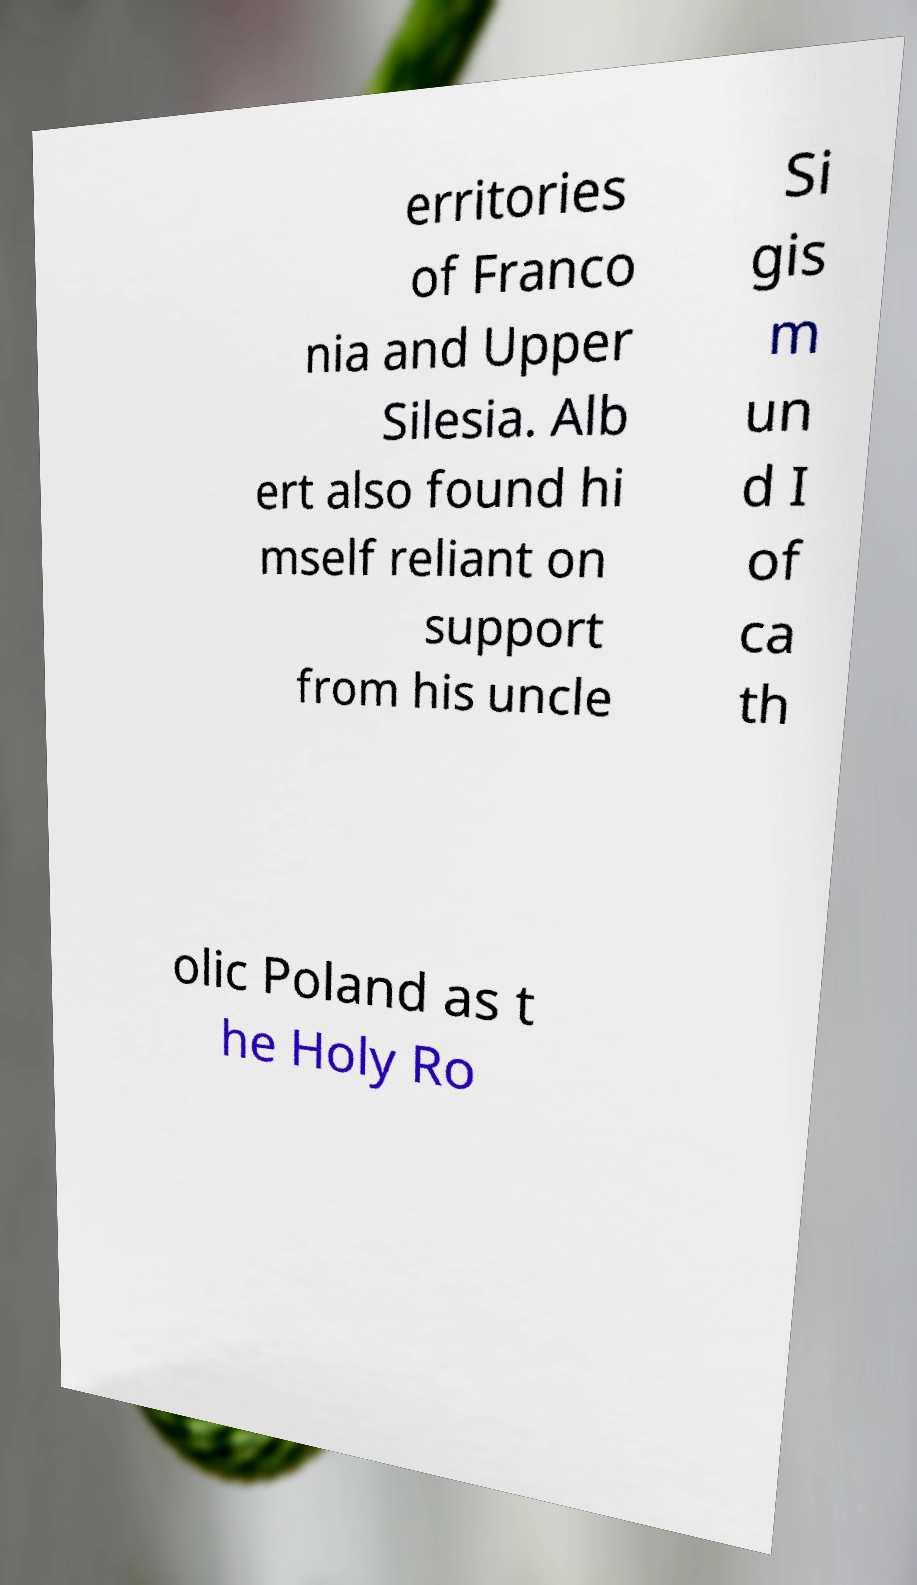Could you extract and type out the text from this image? erritories of Franco nia and Upper Silesia. Alb ert also found hi mself reliant on support from his uncle Si gis m un d I of ca th olic Poland as t he Holy Ro 